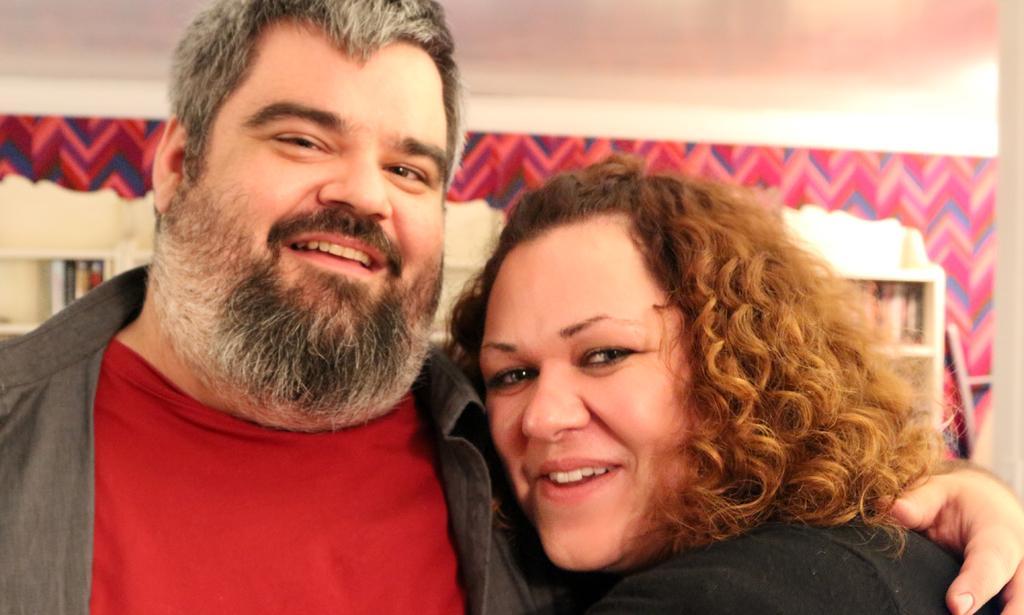Please provide a concise description of this image. In this image there is a man on the left side who kept his hand on the woman who is beside him. In the background there are shelves in which there are books. At the top there is ceiling. There is a design on the wall. 